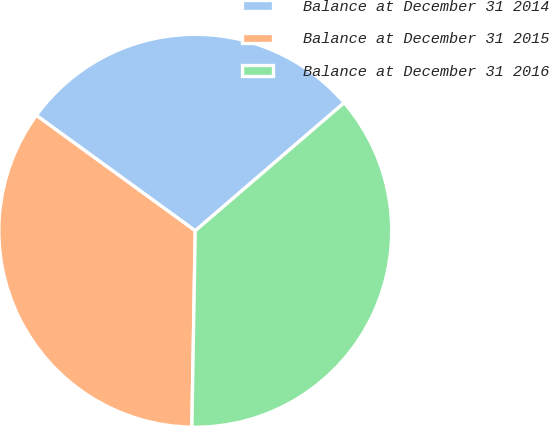Convert chart. <chart><loc_0><loc_0><loc_500><loc_500><pie_chart><fcel>Balance at December 31 2014<fcel>Balance at December 31 2015<fcel>Balance at December 31 2016<nl><fcel>28.7%<fcel>34.72%<fcel>36.57%<nl></chart> 